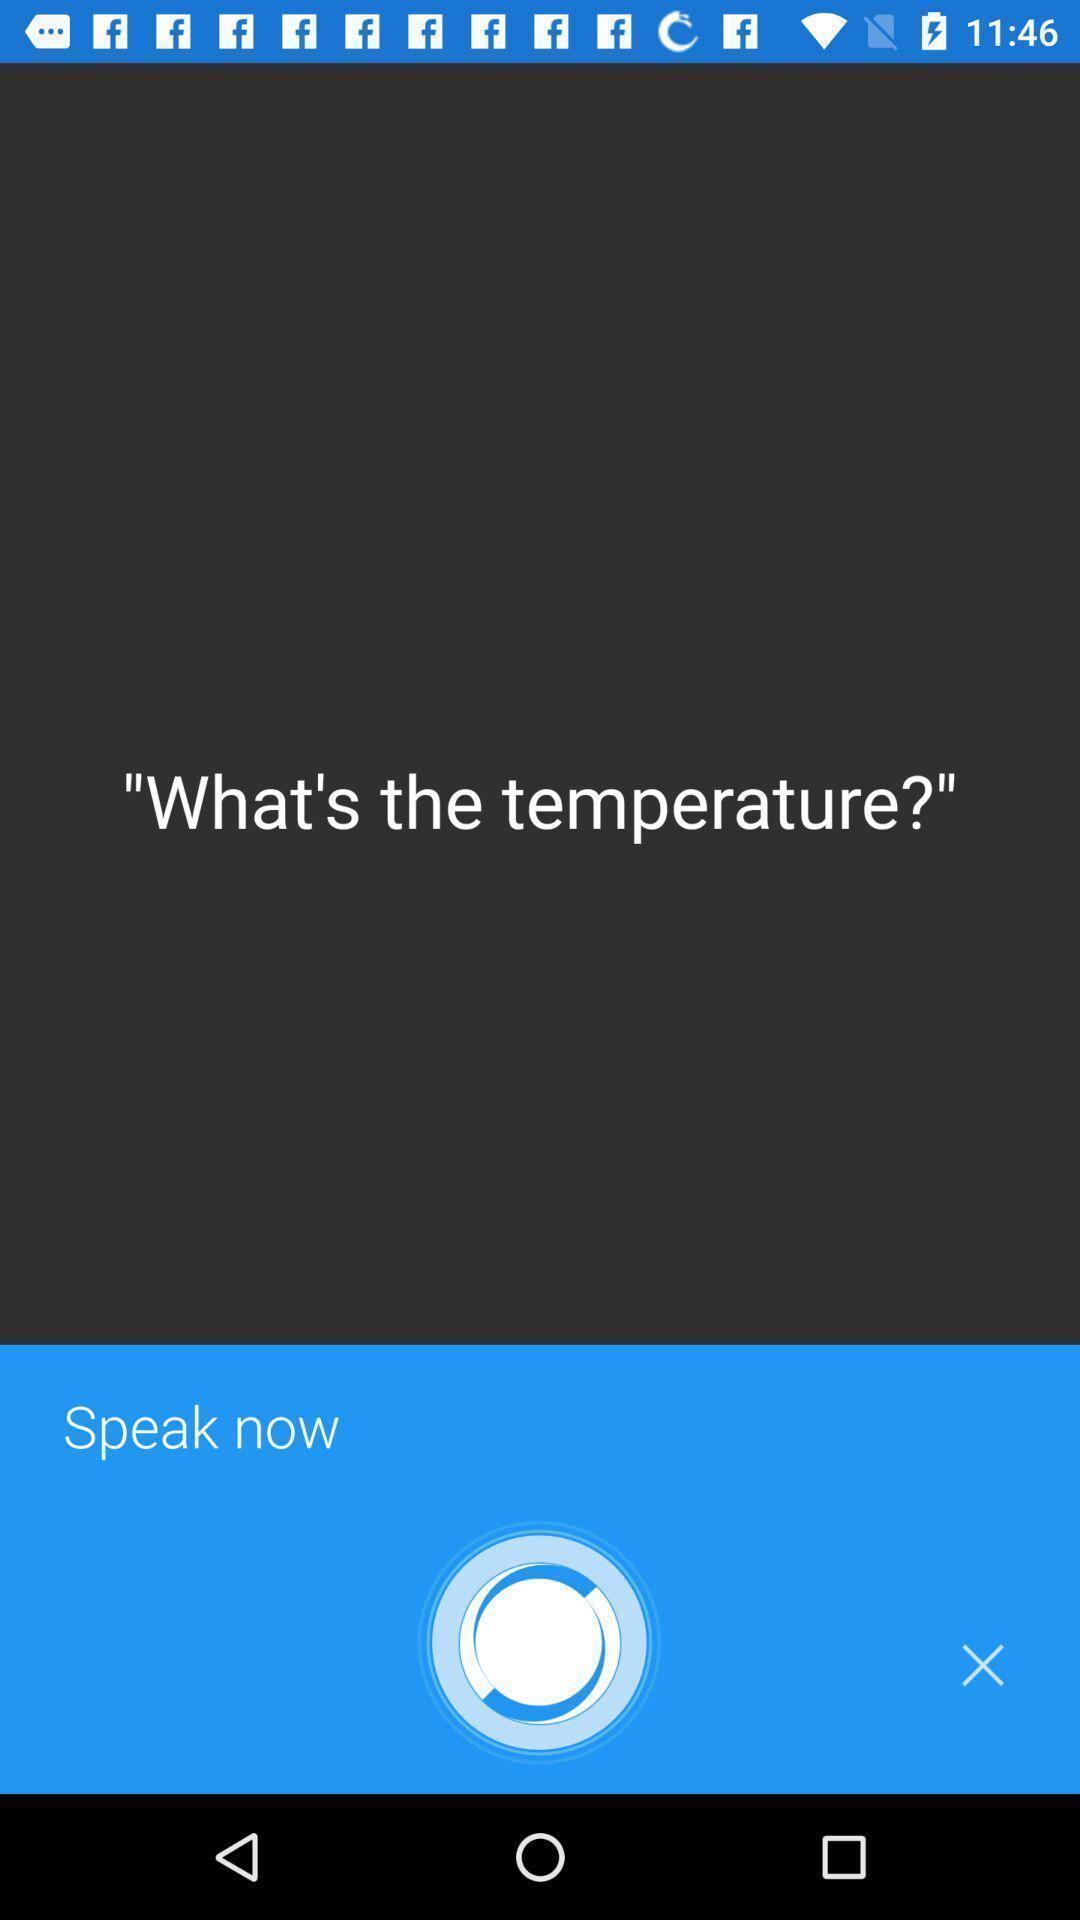Describe this image in words. Screen showing the virtual assistant page. 